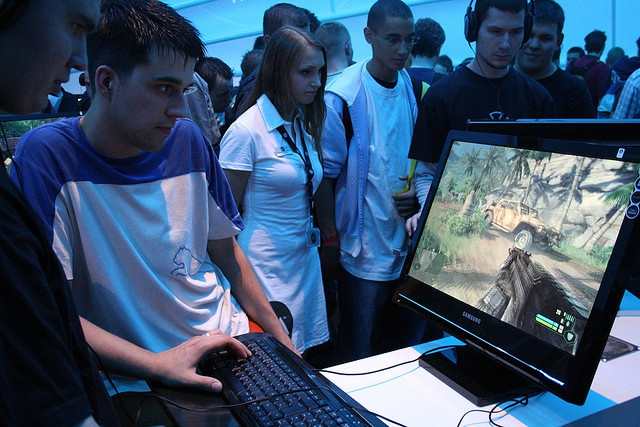Describe the objects in this image and their specific colors. I can see people in navy, black, gray, and blue tones, tv in navy, black, darkgray, lightgray, and gray tones, people in navy, black, and lightpink tones, people in navy, black, blue, and lightblue tones, and people in navy, black, blue, and gray tones in this image. 